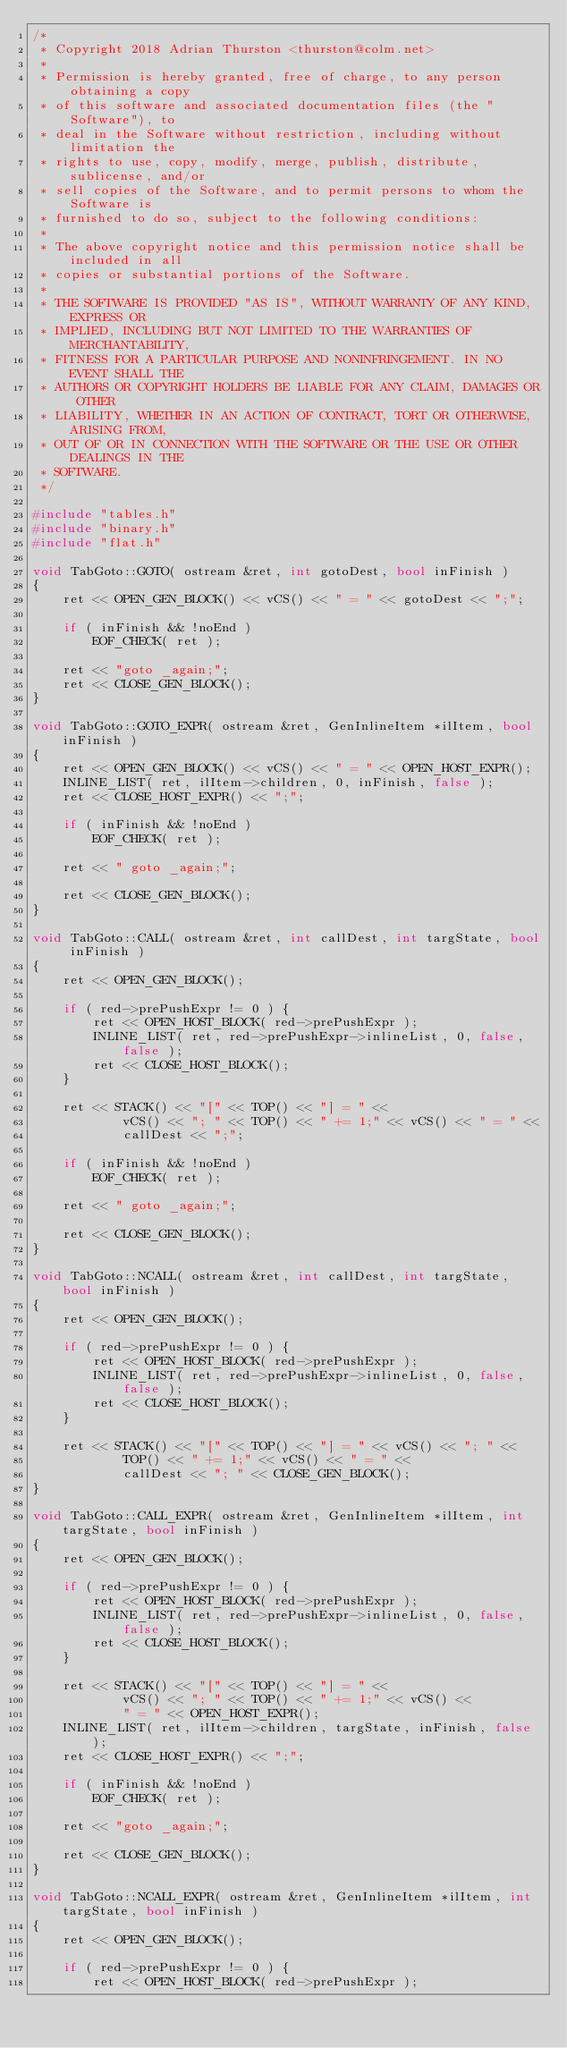<code> <loc_0><loc_0><loc_500><loc_500><_C++_>/*
 * Copyright 2018 Adrian Thurston <thurston@colm.net>
 *
 * Permission is hereby granted, free of charge, to any person obtaining a copy
 * of this software and associated documentation files (the "Software"), to
 * deal in the Software without restriction, including without limitation the
 * rights to use, copy, modify, merge, publish, distribute, sublicense, and/or
 * sell copies of the Software, and to permit persons to whom the Software is
 * furnished to do so, subject to the following conditions:
 *
 * The above copyright notice and this permission notice shall be included in all
 * copies or substantial portions of the Software.
 *
 * THE SOFTWARE IS PROVIDED "AS IS", WITHOUT WARRANTY OF ANY KIND, EXPRESS OR
 * IMPLIED, INCLUDING BUT NOT LIMITED TO THE WARRANTIES OF MERCHANTABILITY,
 * FITNESS FOR A PARTICULAR PURPOSE AND NONINFRINGEMENT. IN NO EVENT SHALL THE
 * AUTHORS OR COPYRIGHT HOLDERS BE LIABLE FOR ANY CLAIM, DAMAGES OR OTHER
 * LIABILITY, WHETHER IN AN ACTION OF CONTRACT, TORT OR OTHERWISE, ARISING FROM,
 * OUT OF OR IN CONNECTION WITH THE SOFTWARE OR THE USE OR OTHER DEALINGS IN THE
 * SOFTWARE.
 */

#include "tables.h"
#include "binary.h"
#include "flat.h"

void TabGoto::GOTO( ostream &ret, int gotoDest, bool inFinish )
{
	ret << OPEN_GEN_BLOCK() << vCS() << " = " << gotoDest << ";";

	if ( inFinish && !noEnd )
		EOF_CHECK( ret );

	ret << "goto _again;";
	ret << CLOSE_GEN_BLOCK();
}

void TabGoto::GOTO_EXPR( ostream &ret, GenInlineItem *ilItem, bool inFinish )
{
	ret << OPEN_GEN_BLOCK() << vCS() << " = " << OPEN_HOST_EXPR();
	INLINE_LIST( ret, ilItem->children, 0, inFinish, false );
	ret << CLOSE_HOST_EXPR() << ";";

	if ( inFinish && !noEnd )
		EOF_CHECK( ret );
	
	ret << " goto _again;";
	
	ret << CLOSE_GEN_BLOCK();
}

void TabGoto::CALL( ostream &ret, int callDest, int targState, bool inFinish )
{
	ret << OPEN_GEN_BLOCK();

	if ( red->prePushExpr != 0 ) {
		ret << OPEN_HOST_BLOCK( red->prePushExpr );
		INLINE_LIST( ret, red->prePushExpr->inlineList, 0, false, false );
		ret << CLOSE_HOST_BLOCK();
	}

	ret << STACK() << "[" << TOP() << "] = " <<
			vCS() << "; " << TOP() << " += 1;" << vCS() << " = " << 
			callDest << ";";

	if ( inFinish && !noEnd )
		EOF_CHECK( ret );

	ret << " goto _again;";

	ret << CLOSE_GEN_BLOCK();
}

void TabGoto::NCALL( ostream &ret, int callDest, int targState, bool inFinish )
{
	ret << OPEN_GEN_BLOCK();

	if ( red->prePushExpr != 0 ) {
		ret << OPEN_HOST_BLOCK( red->prePushExpr );
		INLINE_LIST( ret, red->prePushExpr->inlineList, 0, false, false );
		ret << CLOSE_HOST_BLOCK();
	}

	ret << STACK() << "[" << TOP() << "] = " << vCS() << "; " <<
			TOP() << " += 1;" << vCS() << " = " << 
			callDest << "; " << CLOSE_GEN_BLOCK();
}

void TabGoto::CALL_EXPR( ostream &ret, GenInlineItem *ilItem, int targState, bool inFinish )
{
	ret << OPEN_GEN_BLOCK();

	if ( red->prePushExpr != 0 ) {
		ret << OPEN_HOST_BLOCK( red->prePushExpr );
		INLINE_LIST( ret, red->prePushExpr->inlineList, 0, false, false );
		ret << CLOSE_HOST_BLOCK();
	}

	ret << STACK() << "[" << TOP() << "] = " <<
			vCS() << "; " << TOP() << " += 1;" << vCS() <<
			" = " << OPEN_HOST_EXPR();
	INLINE_LIST( ret, ilItem->children, targState, inFinish, false );
	ret << CLOSE_HOST_EXPR() << ";";

	if ( inFinish && !noEnd )
		EOF_CHECK( ret );

	ret << "goto _again;";

	ret << CLOSE_GEN_BLOCK();
}

void TabGoto::NCALL_EXPR( ostream &ret, GenInlineItem *ilItem, int targState, bool inFinish )
{
	ret << OPEN_GEN_BLOCK();

	if ( red->prePushExpr != 0 ) {
		ret << OPEN_HOST_BLOCK( red->prePushExpr );</code> 